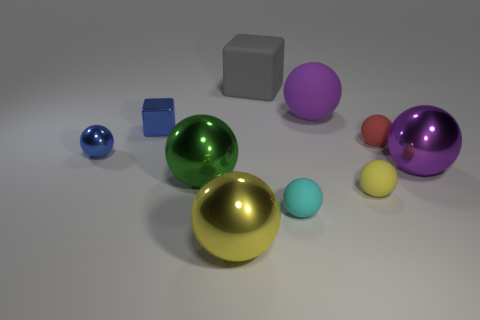Subtract all large metal spheres. How many spheres are left? 5 Subtract all purple blocks. How many purple balls are left? 2 Subtract all spheres. How many objects are left? 2 Subtract all yellow balls. How many balls are left? 6 Subtract 0 cyan cylinders. How many objects are left? 10 Subtract 1 spheres. How many spheres are left? 7 Subtract all blue cubes. Subtract all red cylinders. How many cubes are left? 1 Subtract all large brown matte cubes. Subtract all tiny yellow objects. How many objects are left? 9 Add 9 small blue metal blocks. How many small blue metal blocks are left? 10 Add 1 cubes. How many cubes exist? 3 